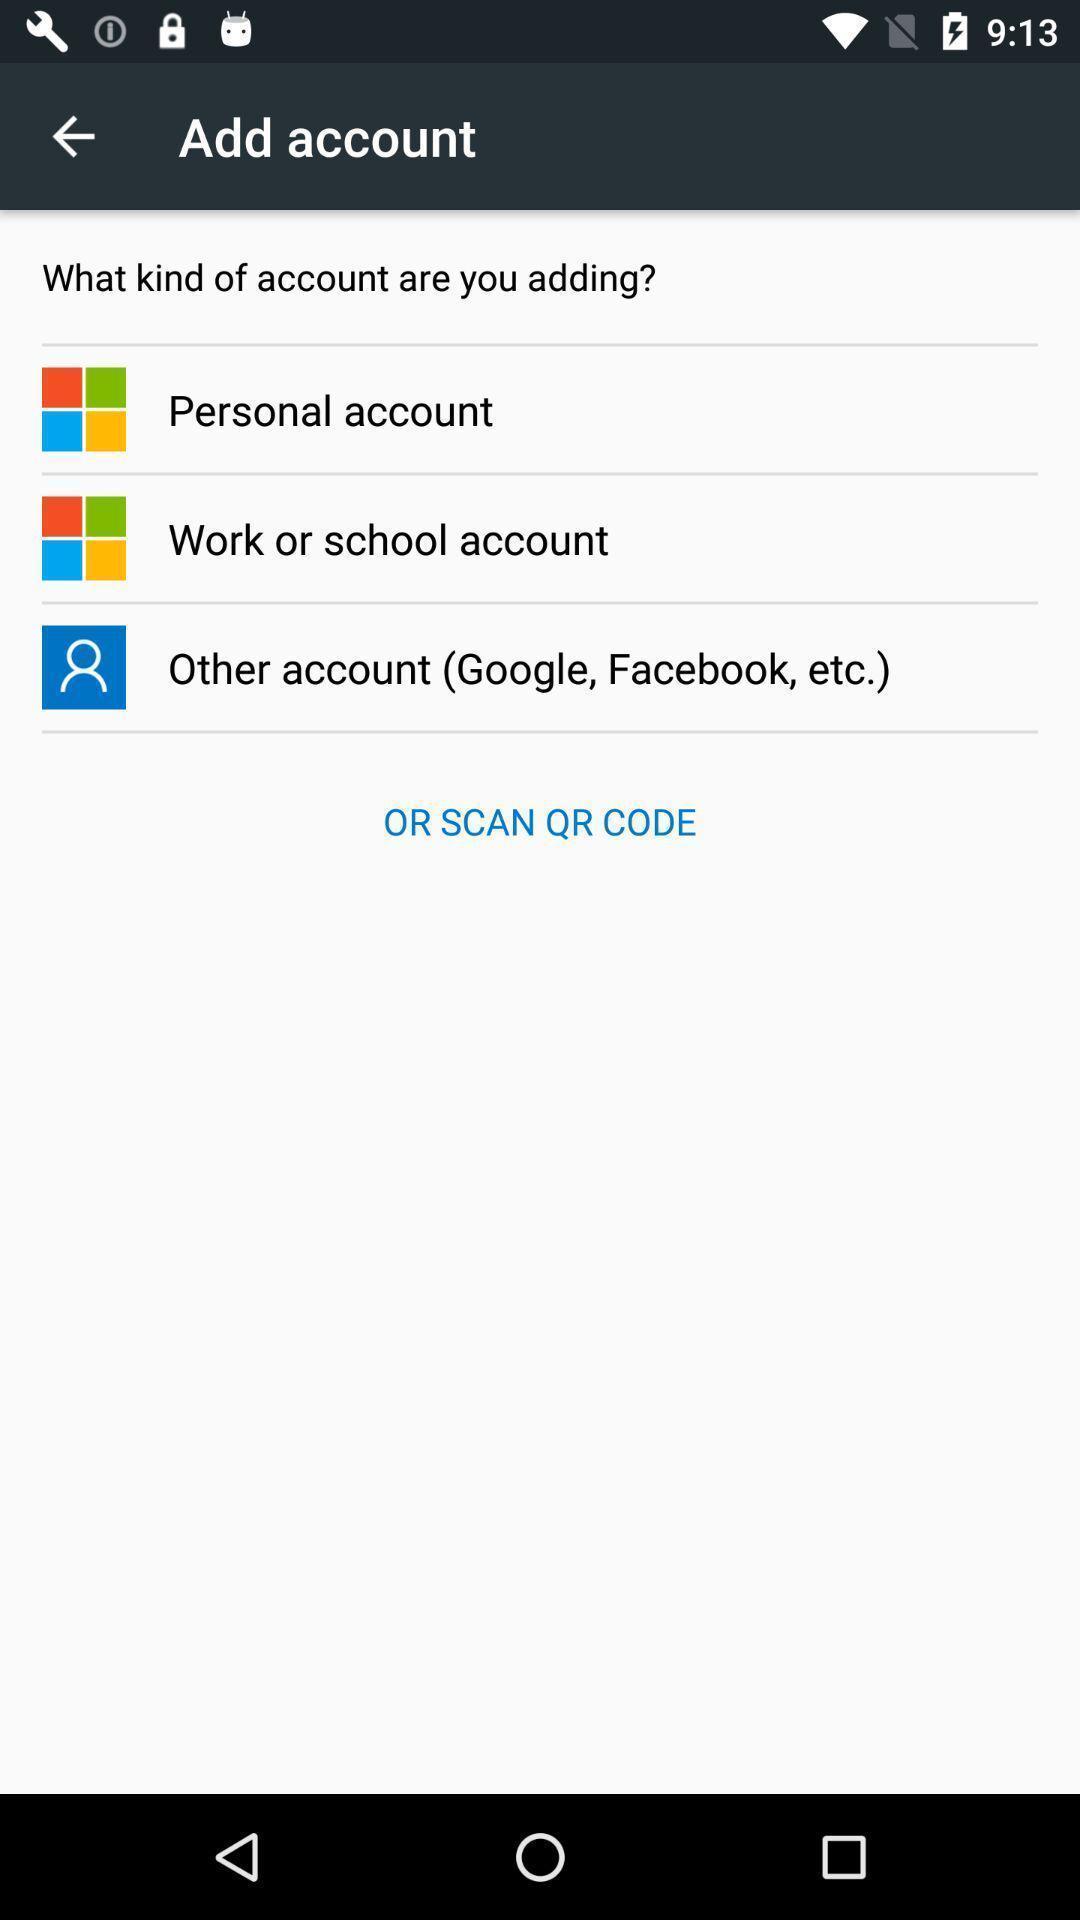Describe the content in this image. Screen displaying multiple account options with icons. 